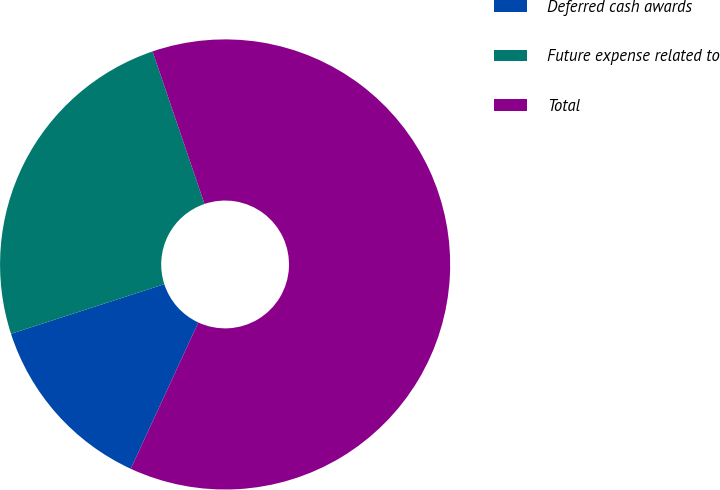Convert chart. <chart><loc_0><loc_0><loc_500><loc_500><pie_chart><fcel>Deferred cash awards<fcel>Future expense related to<fcel>Total<nl><fcel>13.13%<fcel>24.76%<fcel>62.11%<nl></chart> 